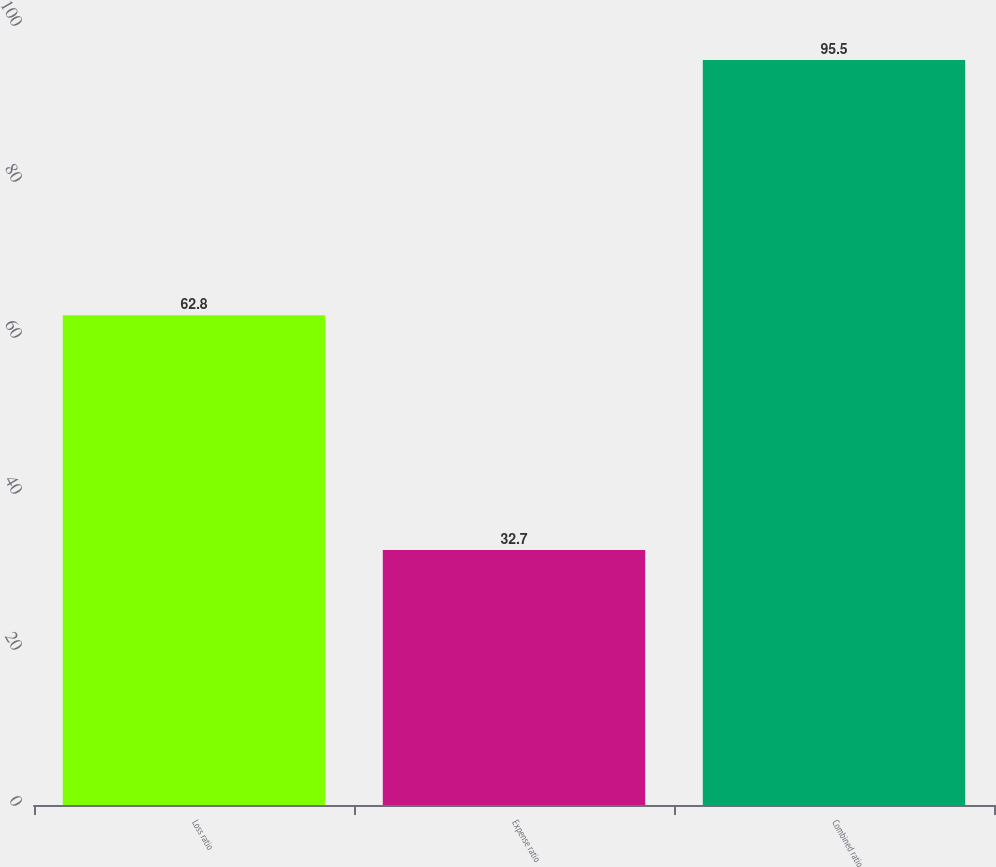Convert chart. <chart><loc_0><loc_0><loc_500><loc_500><bar_chart><fcel>Loss ratio<fcel>Expense ratio<fcel>Combined ratio<nl><fcel>62.8<fcel>32.7<fcel>95.5<nl></chart> 